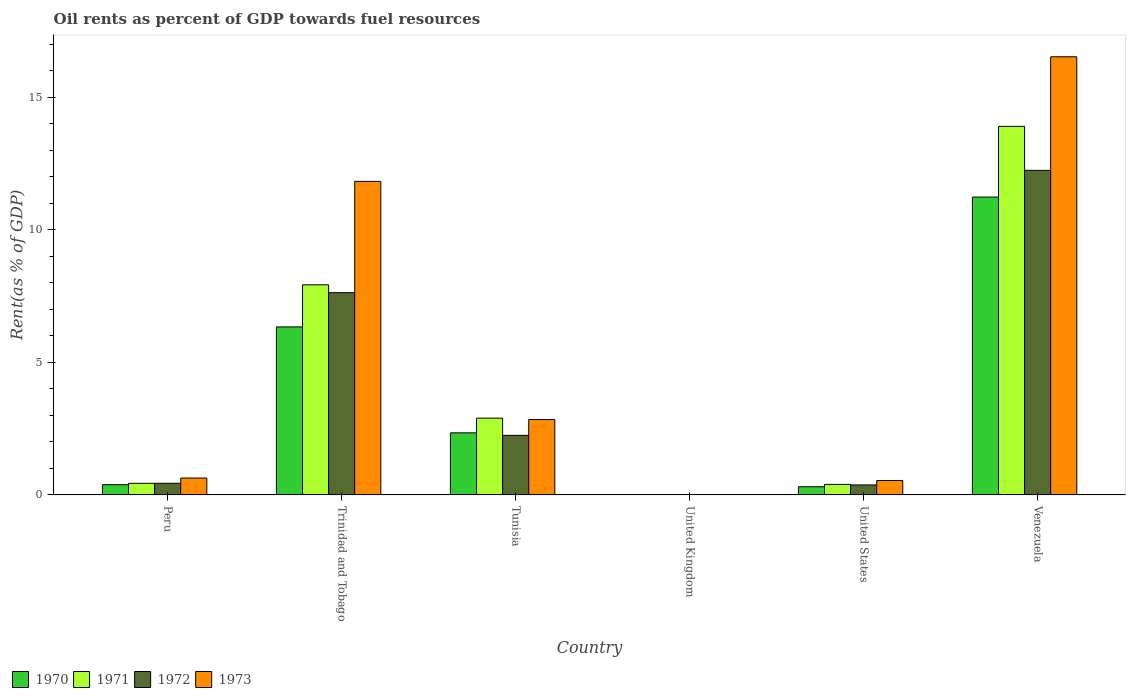How many groups of bars are there?
Provide a short and direct response. 6. Are the number of bars on each tick of the X-axis equal?
Provide a succinct answer. Yes. What is the oil rent in 1972 in Peru?
Keep it short and to the point. 0.44. Across all countries, what is the maximum oil rent in 1971?
Your response must be concise. 13.9. Across all countries, what is the minimum oil rent in 1973?
Your response must be concise. 0. In which country was the oil rent in 1970 maximum?
Keep it short and to the point. Venezuela. In which country was the oil rent in 1971 minimum?
Your answer should be compact. United Kingdom. What is the total oil rent in 1971 in the graph?
Provide a succinct answer. 25.55. What is the difference between the oil rent in 1972 in United States and that in Venezuela?
Provide a short and direct response. -11.86. What is the difference between the oil rent in 1970 in Tunisia and the oil rent in 1973 in Venezuela?
Provide a short and direct response. -14.18. What is the average oil rent in 1970 per country?
Your answer should be very brief. 3.43. What is the difference between the oil rent of/in 1973 and oil rent of/in 1971 in Peru?
Make the answer very short. 0.2. In how many countries, is the oil rent in 1973 greater than 11 %?
Give a very brief answer. 2. What is the ratio of the oil rent in 1972 in United Kingdom to that in United States?
Your answer should be compact. 0. Is the oil rent in 1970 in Tunisia less than that in Venezuela?
Your response must be concise. Yes. Is the difference between the oil rent in 1973 in Trinidad and Tobago and Venezuela greater than the difference between the oil rent in 1971 in Trinidad and Tobago and Venezuela?
Ensure brevity in your answer.  Yes. What is the difference between the highest and the second highest oil rent in 1972?
Your answer should be very brief. -9.99. What is the difference between the highest and the lowest oil rent in 1970?
Keep it short and to the point. 11.23. Is the sum of the oil rent in 1972 in Peru and Venezuela greater than the maximum oil rent in 1970 across all countries?
Make the answer very short. Yes. What does the 1st bar from the left in United States represents?
Your answer should be compact. 1970. What does the 4th bar from the right in Peru represents?
Provide a short and direct response. 1970. Is it the case that in every country, the sum of the oil rent in 1972 and oil rent in 1973 is greater than the oil rent in 1970?
Provide a short and direct response. Yes. How many countries are there in the graph?
Provide a succinct answer. 6. What is the difference between two consecutive major ticks on the Y-axis?
Your answer should be compact. 5. Are the values on the major ticks of Y-axis written in scientific E-notation?
Your response must be concise. No. What is the title of the graph?
Offer a terse response. Oil rents as percent of GDP towards fuel resources. What is the label or title of the Y-axis?
Give a very brief answer. Rent(as % of GDP). What is the Rent(as % of GDP) in 1970 in Peru?
Provide a short and direct response. 0.39. What is the Rent(as % of GDP) in 1971 in Peru?
Ensure brevity in your answer.  0.44. What is the Rent(as % of GDP) in 1972 in Peru?
Keep it short and to the point. 0.44. What is the Rent(as % of GDP) in 1973 in Peru?
Ensure brevity in your answer.  0.64. What is the Rent(as % of GDP) of 1970 in Trinidad and Tobago?
Keep it short and to the point. 6.33. What is the Rent(as % of GDP) of 1971 in Trinidad and Tobago?
Provide a succinct answer. 7.92. What is the Rent(as % of GDP) of 1972 in Trinidad and Tobago?
Offer a terse response. 7.63. What is the Rent(as % of GDP) in 1973 in Trinidad and Tobago?
Make the answer very short. 11.82. What is the Rent(as % of GDP) in 1970 in Tunisia?
Ensure brevity in your answer.  2.34. What is the Rent(as % of GDP) of 1971 in Tunisia?
Your answer should be compact. 2.89. What is the Rent(as % of GDP) of 1972 in Tunisia?
Keep it short and to the point. 2.25. What is the Rent(as % of GDP) of 1973 in Tunisia?
Give a very brief answer. 2.84. What is the Rent(as % of GDP) in 1970 in United Kingdom?
Your response must be concise. 0. What is the Rent(as % of GDP) of 1971 in United Kingdom?
Provide a succinct answer. 0. What is the Rent(as % of GDP) of 1972 in United Kingdom?
Your response must be concise. 0. What is the Rent(as % of GDP) in 1973 in United Kingdom?
Your answer should be very brief. 0. What is the Rent(as % of GDP) of 1970 in United States?
Keep it short and to the point. 0.31. What is the Rent(as % of GDP) in 1971 in United States?
Your response must be concise. 0.4. What is the Rent(as % of GDP) in 1972 in United States?
Offer a terse response. 0.38. What is the Rent(as % of GDP) in 1973 in United States?
Offer a very short reply. 0.54. What is the Rent(as % of GDP) of 1970 in Venezuela?
Offer a very short reply. 11.23. What is the Rent(as % of GDP) of 1971 in Venezuela?
Offer a terse response. 13.9. What is the Rent(as % of GDP) of 1972 in Venezuela?
Make the answer very short. 12.24. What is the Rent(as % of GDP) of 1973 in Venezuela?
Give a very brief answer. 16.52. Across all countries, what is the maximum Rent(as % of GDP) of 1970?
Offer a very short reply. 11.23. Across all countries, what is the maximum Rent(as % of GDP) of 1971?
Your answer should be very brief. 13.9. Across all countries, what is the maximum Rent(as % of GDP) in 1972?
Provide a succinct answer. 12.24. Across all countries, what is the maximum Rent(as % of GDP) of 1973?
Keep it short and to the point. 16.52. Across all countries, what is the minimum Rent(as % of GDP) in 1970?
Your answer should be compact. 0. Across all countries, what is the minimum Rent(as % of GDP) in 1971?
Provide a short and direct response. 0. Across all countries, what is the minimum Rent(as % of GDP) of 1972?
Keep it short and to the point. 0. Across all countries, what is the minimum Rent(as % of GDP) in 1973?
Your answer should be compact. 0. What is the total Rent(as % of GDP) of 1970 in the graph?
Keep it short and to the point. 20.6. What is the total Rent(as % of GDP) in 1971 in the graph?
Offer a terse response. 25.55. What is the total Rent(as % of GDP) of 1972 in the graph?
Make the answer very short. 22.93. What is the total Rent(as % of GDP) of 1973 in the graph?
Make the answer very short. 32.37. What is the difference between the Rent(as % of GDP) of 1970 in Peru and that in Trinidad and Tobago?
Offer a terse response. -5.95. What is the difference between the Rent(as % of GDP) in 1971 in Peru and that in Trinidad and Tobago?
Your answer should be very brief. -7.49. What is the difference between the Rent(as % of GDP) of 1972 in Peru and that in Trinidad and Tobago?
Provide a short and direct response. -7.19. What is the difference between the Rent(as % of GDP) of 1973 in Peru and that in Trinidad and Tobago?
Make the answer very short. -11.19. What is the difference between the Rent(as % of GDP) in 1970 in Peru and that in Tunisia?
Your response must be concise. -1.95. What is the difference between the Rent(as % of GDP) of 1971 in Peru and that in Tunisia?
Provide a succinct answer. -2.46. What is the difference between the Rent(as % of GDP) of 1972 in Peru and that in Tunisia?
Offer a very short reply. -1.81. What is the difference between the Rent(as % of GDP) in 1973 in Peru and that in Tunisia?
Ensure brevity in your answer.  -2.21. What is the difference between the Rent(as % of GDP) of 1970 in Peru and that in United Kingdom?
Provide a short and direct response. 0.38. What is the difference between the Rent(as % of GDP) in 1971 in Peru and that in United Kingdom?
Give a very brief answer. 0.44. What is the difference between the Rent(as % of GDP) of 1972 in Peru and that in United Kingdom?
Offer a terse response. 0.44. What is the difference between the Rent(as % of GDP) in 1973 in Peru and that in United Kingdom?
Your answer should be very brief. 0.63. What is the difference between the Rent(as % of GDP) of 1970 in Peru and that in United States?
Your response must be concise. 0.08. What is the difference between the Rent(as % of GDP) in 1971 in Peru and that in United States?
Keep it short and to the point. 0.04. What is the difference between the Rent(as % of GDP) in 1972 in Peru and that in United States?
Offer a terse response. 0.06. What is the difference between the Rent(as % of GDP) in 1973 in Peru and that in United States?
Offer a terse response. 0.09. What is the difference between the Rent(as % of GDP) of 1970 in Peru and that in Venezuela?
Your answer should be very brief. -10.85. What is the difference between the Rent(as % of GDP) in 1971 in Peru and that in Venezuela?
Make the answer very short. -13.46. What is the difference between the Rent(as % of GDP) of 1972 in Peru and that in Venezuela?
Your response must be concise. -11.8. What is the difference between the Rent(as % of GDP) of 1973 in Peru and that in Venezuela?
Your answer should be compact. -15.89. What is the difference between the Rent(as % of GDP) in 1970 in Trinidad and Tobago and that in Tunisia?
Make the answer very short. 3.99. What is the difference between the Rent(as % of GDP) in 1971 in Trinidad and Tobago and that in Tunisia?
Keep it short and to the point. 5.03. What is the difference between the Rent(as % of GDP) of 1972 in Trinidad and Tobago and that in Tunisia?
Give a very brief answer. 5.38. What is the difference between the Rent(as % of GDP) of 1973 in Trinidad and Tobago and that in Tunisia?
Offer a very short reply. 8.98. What is the difference between the Rent(as % of GDP) in 1970 in Trinidad and Tobago and that in United Kingdom?
Make the answer very short. 6.33. What is the difference between the Rent(as % of GDP) of 1971 in Trinidad and Tobago and that in United Kingdom?
Your answer should be very brief. 7.92. What is the difference between the Rent(as % of GDP) of 1972 in Trinidad and Tobago and that in United Kingdom?
Offer a very short reply. 7.62. What is the difference between the Rent(as % of GDP) in 1973 in Trinidad and Tobago and that in United Kingdom?
Your response must be concise. 11.82. What is the difference between the Rent(as % of GDP) of 1970 in Trinidad and Tobago and that in United States?
Keep it short and to the point. 6.03. What is the difference between the Rent(as % of GDP) of 1971 in Trinidad and Tobago and that in United States?
Provide a succinct answer. 7.53. What is the difference between the Rent(as % of GDP) of 1972 in Trinidad and Tobago and that in United States?
Keep it short and to the point. 7.25. What is the difference between the Rent(as % of GDP) in 1973 in Trinidad and Tobago and that in United States?
Make the answer very short. 11.28. What is the difference between the Rent(as % of GDP) in 1970 in Trinidad and Tobago and that in Venezuela?
Make the answer very short. -4.9. What is the difference between the Rent(as % of GDP) of 1971 in Trinidad and Tobago and that in Venezuela?
Offer a terse response. -5.97. What is the difference between the Rent(as % of GDP) of 1972 in Trinidad and Tobago and that in Venezuela?
Give a very brief answer. -4.61. What is the difference between the Rent(as % of GDP) of 1973 in Trinidad and Tobago and that in Venezuela?
Offer a very short reply. -4.7. What is the difference between the Rent(as % of GDP) of 1970 in Tunisia and that in United Kingdom?
Your response must be concise. 2.34. What is the difference between the Rent(as % of GDP) in 1971 in Tunisia and that in United Kingdom?
Give a very brief answer. 2.89. What is the difference between the Rent(as % of GDP) in 1972 in Tunisia and that in United Kingdom?
Provide a succinct answer. 2.24. What is the difference between the Rent(as % of GDP) of 1973 in Tunisia and that in United Kingdom?
Offer a terse response. 2.84. What is the difference between the Rent(as % of GDP) in 1970 in Tunisia and that in United States?
Ensure brevity in your answer.  2.03. What is the difference between the Rent(as % of GDP) of 1971 in Tunisia and that in United States?
Your answer should be very brief. 2.5. What is the difference between the Rent(as % of GDP) of 1972 in Tunisia and that in United States?
Offer a very short reply. 1.87. What is the difference between the Rent(as % of GDP) of 1973 in Tunisia and that in United States?
Provide a short and direct response. 2.3. What is the difference between the Rent(as % of GDP) in 1970 in Tunisia and that in Venezuela?
Your answer should be very brief. -8.89. What is the difference between the Rent(as % of GDP) in 1971 in Tunisia and that in Venezuela?
Ensure brevity in your answer.  -11. What is the difference between the Rent(as % of GDP) of 1972 in Tunisia and that in Venezuela?
Give a very brief answer. -9.99. What is the difference between the Rent(as % of GDP) of 1973 in Tunisia and that in Venezuela?
Offer a terse response. -13.68. What is the difference between the Rent(as % of GDP) in 1970 in United Kingdom and that in United States?
Offer a terse response. -0.31. What is the difference between the Rent(as % of GDP) in 1971 in United Kingdom and that in United States?
Give a very brief answer. -0.4. What is the difference between the Rent(as % of GDP) in 1972 in United Kingdom and that in United States?
Your answer should be very brief. -0.37. What is the difference between the Rent(as % of GDP) of 1973 in United Kingdom and that in United States?
Your response must be concise. -0.54. What is the difference between the Rent(as % of GDP) in 1970 in United Kingdom and that in Venezuela?
Your answer should be compact. -11.23. What is the difference between the Rent(as % of GDP) in 1971 in United Kingdom and that in Venezuela?
Your answer should be very brief. -13.9. What is the difference between the Rent(as % of GDP) of 1972 in United Kingdom and that in Venezuela?
Offer a very short reply. -12.24. What is the difference between the Rent(as % of GDP) of 1973 in United Kingdom and that in Venezuela?
Make the answer very short. -16.52. What is the difference between the Rent(as % of GDP) of 1970 in United States and that in Venezuela?
Offer a terse response. -10.92. What is the difference between the Rent(as % of GDP) in 1971 in United States and that in Venezuela?
Your answer should be very brief. -13.5. What is the difference between the Rent(as % of GDP) in 1972 in United States and that in Venezuela?
Your response must be concise. -11.86. What is the difference between the Rent(as % of GDP) of 1973 in United States and that in Venezuela?
Your answer should be compact. -15.98. What is the difference between the Rent(as % of GDP) of 1970 in Peru and the Rent(as % of GDP) of 1971 in Trinidad and Tobago?
Provide a succinct answer. -7.54. What is the difference between the Rent(as % of GDP) of 1970 in Peru and the Rent(as % of GDP) of 1972 in Trinidad and Tobago?
Provide a short and direct response. -7.24. What is the difference between the Rent(as % of GDP) in 1970 in Peru and the Rent(as % of GDP) in 1973 in Trinidad and Tobago?
Keep it short and to the point. -11.44. What is the difference between the Rent(as % of GDP) of 1971 in Peru and the Rent(as % of GDP) of 1972 in Trinidad and Tobago?
Give a very brief answer. -7.19. What is the difference between the Rent(as % of GDP) in 1971 in Peru and the Rent(as % of GDP) in 1973 in Trinidad and Tobago?
Make the answer very short. -11.39. What is the difference between the Rent(as % of GDP) of 1972 in Peru and the Rent(as % of GDP) of 1973 in Trinidad and Tobago?
Your response must be concise. -11.38. What is the difference between the Rent(as % of GDP) in 1970 in Peru and the Rent(as % of GDP) in 1971 in Tunisia?
Ensure brevity in your answer.  -2.51. What is the difference between the Rent(as % of GDP) in 1970 in Peru and the Rent(as % of GDP) in 1972 in Tunisia?
Keep it short and to the point. -1.86. What is the difference between the Rent(as % of GDP) in 1970 in Peru and the Rent(as % of GDP) in 1973 in Tunisia?
Your answer should be very brief. -2.46. What is the difference between the Rent(as % of GDP) of 1971 in Peru and the Rent(as % of GDP) of 1972 in Tunisia?
Provide a short and direct response. -1.81. What is the difference between the Rent(as % of GDP) in 1971 in Peru and the Rent(as % of GDP) in 1973 in Tunisia?
Keep it short and to the point. -2.4. What is the difference between the Rent(as % of GDP) in 1972 in Peru and the Rent(as % of GDP) in 1973 in Tunisia?
Your answer should be compact. -2.4. What is the difference between the Rent(as % of GDP) in 1970 in Peru and the Rent(as % of GDP) in 1971 in United Kingdom?
Offer a terse response. 0.38. What is the difference between the Rent(as % of GDP) in 1970 in Peru and the Rent(as % of GDP) in 1972 in United Kingdom?
Keep it short and to the point. 0.38. What is the difference between the Rent(as % of GDP) of 1970 in Peru and the Rent(as % of GDP) of 1973 in United Kingdom?
Keep it short and to the point. 0.38. What is the difference between the Rent(as % of GDP) of 1971 in Peru and the Rent(as % of GDP) of 1972 in United Kingdom?
Make the answer very short. 0.44. What is the difference between the Rent(as % of GDP) of 1971 in Peru and the Rent(as % of GDP) of 1973 in United Kingdom?
Provide a short and direct response. 0.43. What is the difference between the Rent(as % of GDP) of 1972 in Peru and the Rent(as % of GDP) of 1973 in United Kingdom?
Keep it short and to the point. 0.44. What is the difference between the Rent(as % of GDP) of 1970 in Peru and the Rent(as % of GDP) of 1971 in United States?
Make the answer very short. -0.01. What is the difference between the Rent(as % of GDP) in 1970 in Peru and the Rent(as % of GDP) in 1972 in United States?
Ensure brevity in your answer.  0.01. What is the difference between the Rent(as % of GDP) in 1970 in Peru and the Rent(as % of GDP) in 1973 in United States?
Make the answer very short. -0.16. What is the difference between the Rent(as % of GDP) in 1971 in Peru and the Rent(as % of GDP) in 1972 in United States?
Offer a very short reply. 0.06. What is the difference between the Rent(as % of GDP) of 1971 in Peru and the Rent(as % of GDP) of 1973 in United States?
Make the answer very short. -0.11. What is the difference between the Rent(as % of GDP) of 1972 in Peru and the Rent(as % of GDP) of 1973 in United States?
Your answer should be very brief. -0.1. What is the difference between the Rent(as % of GDP) in 1970 in Peru and the Rent(as % of GDP) in 1971 in Venezuela?
Ensure brevity in your answer.  -13.51. What is the difference between the Rent(as % of GDP) in 1970 in Peru and the Rent(as % of GDP) in 1972 in Venezuela?
Your answer should be very brief. -11.85. What is the difference between the Rent(as % of GDP) of 1970 in Peru and the Rent(as % of GDP) of 1973 in Venezuela?
Make the answer very short. -16.14. What is the difference between the Rent(as % of GDP) of 1971 in Peru and the Rent(as % of GDP) of 1972 in Venezuela?
Give a very brief answer. -11.8. What is the difference between the Rent(as % of GDP) in 1971 in Peru and the Rent(as % of GDP) in 1973 in Venezuela?
Your answer should be very brief. -16.08. What is the difference between the Rent(as % of GDP) in 1972 in Peru and the Rent(as % of GDP) in 1973 in Venezuela?
Ensure brevity in your answer.  -16.08. What is the difference between the Rent(as % of GDP) of 1970 in Trinidad and Tobago and the Rent(as % of GDP) of 1971 in Tunisia?
Offer a very short reply. 3.44. What is the difference between the Rent(as % of GDP) of 1970 in Trinidad and Tobago and the Rent(as % of GDP) of 1972 in Tunisia?
Ensure brevity in your answer.  4.09. What is the difference between the Rent(as % of GDP) in 1970 in Trinidad and Tobago and the Rent(as % of GDP) in 1973 in Tunisia?
Your answer should be compact. 3.49. What is the difference between the Rent(as % of GDP) in 1971 in Trinidad and Tobago and the Rent(as % of GDP) in 1972 in Tunisia?
Offer a very short reply. 5.68. What is the difference between the Rent(as % of GDP) in 1971 in Trinidad and Tobago and the Rent(as % of GDP) in 1973 in Tunisia?
Your answer should be very brief. 5.08. What is the difference between the Rent(as % of GDP) of 1972 in Trinidad and Tobago and the Rent(as % of GDP) of 1973 in Tunisia?
Offer a terse response. 4.78. What is the difference between the Rent(as % of GDP) in 1970 in Trinidad and Tobago and the Rent(as % of GDP) in 1971 in United Kingdom?
Offer a very short reply. 6.33. What is the difference between the Rent(as % of GDP) of 1970 in Trinidad and Tobago and the Rent(as % of GDP) of 1972 in United Kingdom?
Ensure brevity in your answer.  6.33. What is the difference between the Rent(as % of GDP) in 1970 in Trinidad and Tobago and the Rent(as % of GDP) in 1973 in United Kingdom?
Offer a terse response. 6.33. What is the difference between the Rent(as % of GDP) of 1971 in Trinidad and Tobago and the Rent(as % of GDP) of 1972 in United Kingdom?
Make the answer very short. 7.92. What is the difference between the Rent(as % of GDP) of 1971 in Trinidad and Tobago and the Rent(as % of GDP) of 1973 in United Kingdom?
Provide a succinct answer. 7.92. What is the difference between the Rent(as % of GDP) of 1972 in Trinidad and Tobago and the Rent(as % of GDP) of 1973 in United Kingdom?
Provide a short and direct response. 7.62. What is the difference between the Rent(as % of GDP) of 1970 in Trinidad and Tobago and the Rent(as % of GDP) of 1971 in United States?
Offer a very short reply. 5.94. What is the difference between the Rent(as % of GDP) of 1970 in Trinidad and Tobago and the Rent(as % of GDP) of 1972 in United States?
Offer a very short reply. 5.96. What is the difference between the Rent(as % of GDP) of 1970 in Trinidad and Tobago and the Rent(as % of GDP) of 1973 in United States?
Your answer should be compact. 5.79. What is the difference between the Rent(as % of GDP) of 1971 in Trinidad and Tobago and the Rent(as % of GDP) of 1972 in United States?
Ensure brevity in your answer.  7.55. What is the difference between the Rent(as % of GDP) of 1971 in Trinidad and Tobago and the Rent(as % of GDP) of 1973 in United States?
Your answer should be compact. 7.38. What is the difference between the Rent(as % of GDP) of 1972 in Trinidad and Tobago and the Rent(as % of GDP) of 1973 in United States?
Make the answer very short. 7.08. What is the difference between the Rent(as % of GDP) in 1970 in Trinidad and Tobago and the Rent(as % of GDP) in 1971 in Venezuela?
Provide a short and direct response. -7.56. What is the difference between the Rent(as % of GDP) of 1970 in Trinidad and Tobago and the Rent(as % of GDP) of 1972 in Venezuela?
Provide a succinct answer. -5.91. What is the difference between the Rent(as % of GDP) of 1970 in Trinidad and Tobago and the Rent(as % of GDP) of 1973 in Venezuela?
Provide a short and direct response. -10.19. What is the difference between the Rent(as % of GDP) of 1971 in Trinidad and Tobago and the Rent(as % of GDP) of 1972 in Venezuela?
Your response must be concise. -4.32. What is the difference between the Rent(as % of GDP) of 1971 in Trinidad and Tobago and the Rent(as % of GDP) of 1973 in Venezuela?
Offer a very short reply. -8.6. What is the difference between the Rent(as % of GDP) in 1972 in Trinidad and Tobago and the Rent(as % of GDP) in 1973 in Venezuela?
Your answer should be very brief. -8.9. What is the difference between the Rent(as % of GDP) of 1970 in Tunisia and the Rent(as % of GDP) of 1971 in United Kingdom?
Provide a succinct answer. 2.34. What is the difference between the Rent(as % of GDP) of 1970 in Tunisia and the Rent(as % of GDP) of 1972 in United Kingdom?
Offer a terse response. 2.34. What is the difference between the Rent(as % of GDP) of 1970 in Tunisia and the Rent(as % of GDP) of 1973 in United Kingdom?
Ensure brevity in your answer.  2.34. What is the difference between the Rent(as % of GDP) of 1971 in Tunisia and the Rent(as % of GDP) of 1972 in United Kingdom?
Your response must be concise. 2.89. What is the difference between the Rent(as % of GDP) of 1971 in Tunisia and the Rent(as % of GDP) of 1973 in United Kingdom?
Your answer should be very brief. 2.89. What is the difference between the Rent(as % of GDP) in 1972 in Tunisia and the Rent(as % of GDP) in 1973 in United Kingdom?
Your answer should be very brief. 2.24. What is the difference between the Rent(as % of GDP) of 1970 in Tunisia and the Rent(as % of GDP) of 1971 in United States?
Provide a succinct answer. 1.94. What is the difference between the Rent(as % of GDP) in 1970 in Tunisia and the Rent(as % of GDP) in 1972 in United States?
Give a very brief answer. 1.96. What is the difference between the Rent(as % of GDP) of 1970 in Tunisia and the Rent(as % of GDP) of 1973 in United States?
Offer a very short reply. 1.8. What is the difference between the Rent(as % of GDP) in 1971 in Tunisia and the Rent(as % of GDP) in 1972 in United States?
Provide a short and direct response. 2.52. What is the difference between the Rent(as % of GDP) of 1971 in Tunisia and the Rent(as % of GDP) of 1973 in United States?
Provide a short and direct response. 2.35. What is the difference between the Rent(as % of GDP) in 1972 in Tunisia and the Rent(as % of GDP) in 1973 in United States?
Ensure brevity in your answer.  1.7. What is the difference between the Rent(as % of GDP) in 1970 in Tunisia and the Rent(as % of GDP) in 1971 in Venezuela?
Your answer should be compact. -11.56. What is the difference between the Rent(as % of GDP) of 1970 in Tunisia and the Rent(as % of GDP) of 1972 in Venezuela?
Provide a short and direct response. -9.9. What is the difference between the Rent(as % of GDP) in 1970 in Tunisia and the Rent(as % of GDP) in 1973 in Venezuela?
Your answer should be compact. -14.18. What is the difference between the Rent(as % of GDP) of 1971 in Tunisia and the Rent(as % of GDP) of 1972 in Venezuela?
Make the answer very short. -9.35. What is the difference between the Rent(as % of GDP) in 1971 in Tunisia and the Rent(as % of GDP) in 1973 in Venezuela?
Provide a short and direct response. -13.63. What is the difference between the Rent(as % of GDP) of 1972 in Tunisia and the Rent(as % of GDP) of 1973 in Venezuela?
Provide a short and direct response. -14.28. What is the difference between the Rent(as % of GDP) of 1970 in United Kingdom and the Rent(as % of GDP) of 1971 in United States?
Provide a succinct answer. -0.4. What is the difference between the Rent(as % of GDP) of 1970 in United Kingdom and the Rent(as % of GDP) of 1972 in United States?
Provide a succinct answer. -0.38. What is the difference between the Rent(as % of GDP) in 1970 in United Kingdom and the Rent(as % of GDP) in 1973 in United States?
Your response must be concise. -0.54. What is the difference between the Rent(as % of GDP) of 1971 in United Kingdom and the Rent(as % of GDP) of 1972 in United States?
Keep it short and to the point. -0.38. What is the difference between the Rent(as % of GDP) in 1971 in United Kingdom and the Rent(as % of GDP) in 1973 in United States?
Keep it short and to the point. -0.54. What is the difference between the Rent(as % of GDP) in 1972 in United Kingdom and the Rent(as % of GDP) in 1973 in United States?
Make the answer very short. -0.54. What is the difference between the Rent(as % of GDP) in 1970 in United Kingdom and the Rent(as % of GDP) in 1971 in Venezuela?
Keep it short and to the point. -13.9. What is the difference between the Rent(as % of GDP) of 1970 in United Kingdom and the Rent(as % of GDP) of 1972 in Venezuela?
Your answer should be compact. -12.24. What is the difference between the Rent(as % of GDP) in 1970 in United Kingdom and the Rent(as % of GDP) in 1973 in Venezuela?
Your response must be concise. -16.52. What is the difference between the Rent(as % of GDP) of 1971 in United Kingdom and the Rent(as % of GDP) of 1972 in Venezuela?
Ensure brevity in your answer.  -12.24. What is the difference between the Rent(as % of GDP) of 1971 in United Kingdom and the Rent(as % of GDP) of 1973 in Venezuela?
Your answer should be compact. -16.52. What is the difference between the Rent(as % of GDP) of 1972 in United Kingdom and the Rent(as % of GDP) of 1973 in Venezuela?
Keep it short and to the point. -16.52. What is the difference between the Rent(as % of GDP) of 1970 in United States and the Rent(as % of GDP) of 1971 in Venezuela?
Your response must be concise. -13.59. What is the difference between the Rent(as % of GDP) of 1970 in United States and the Rent(as % of GDP) of 1972 in Venezuela?
Offer a terse response. -11.93. What is the difference between the Rent(as % of GDP) of 1970 in United States and the Rent(as % of GDP) of 1973 in Venezuela?
Offer a very short reply. -16.21. What is the difference between the Rent(as % of GDP) in 1971 in United States and the Rent(as % of GDP) in 1972 in Venezuela?
Give a very brief answer. -11.84. What is the difference between the Rent(as % of GDP) of 1971 in United States and the Rent(as % of GDP) of 1973 in Venezuela?
Your answer should be very brief. -16.12. What is the difference between the Rent(as % of GDP) of 1972 in United States and the Rent(as % of GDP) of 1973 in Venezuela?
Give a very brief answer. -16.15. What is the average Rent(as % of GDP) in 1970 per country?
Give a very brief answer. 3.43. What is the average Rent(as % of GDP) in 1971 per country?
Provide a succinct answer. 4.26. What is the average Rent(as % of GDP) in 1972 per country?
Your answer should be very brief. 3.82. What is the average Rent(as % of GDP) in 1973 per country?
Provide a short and direct response. 5.39. What is the difference between the Rent(as % of GDP) in 1970 and Rent(as % of GDP) in 1971 in Peru?
Keep it short and to the point. -0.05. What is the difference between the Rent(as % of GDP) of 1970 and Rent(as % of GDP) of 1972 in Peru?
Offer a very short reply. -0.05. What is the difference between the Rent(as % of GDP) in 1970 and Rent(as % of GDP) in 1973 in Peru?
Your response must be concise. -0.25. What is the difference between the Rent(as % of GDP) in 1971 and Rent(as % of GDP) in 1972 in Peru?
Give a very brief answer. -0. What is the difference between the Rent(as % of GDP) of 1971 and Rent(as % of GDP) of 1973 in Peru?
Ensure brevity in your answer.  -0.2. What is the difference between the Rent(as % of GDP) in 1972 and Rent(as % of GDP) in 1973 in Peru?
Give a very brief answer. -0.2. What is the difference between the Rent(as % of GDP) in 1970 and Rent(as % of GDP) in 1971 in Trinidad and Tobago?
Keep it short and to the point. -1.59. What is the difference between the Rent(as % of GDP) in 1970 and Rent(as % of GDP) in 1972 in Trinidad and Tobago?
Provide a short and direct response. -1.29. What is the difference between the Rent(as % of GDP) in 1970 and Rent(as % of GDP) in 1973 in Trinidad and Tobago?
Offer a very short reply. -5.49. What is the difference between the Rent(as % of GDP) of 1971 and Rent(as % of GDP) of 1972 in Trinidad and Tobago?
Make the answer very short. 0.3. What is the difference between the Rent(as % of GDP) in 1971 and Rent(as % of GDP) in 1973 in Trinidad and Tobago?
Your answer should be very brief. -3.9. What is the difference between the Rent(as % of GDP) in 1972 and Rent(as % of GDP) in 1973 in Trinidad and Tobago?
Your answer should be very brief. -4.2. What is the difference between the Rent(as % of GDP) of 1970 and Rent(as % of GDP) of 1971 in Tunisia?
Make the answer very short. -0.55. What is the difference between the Rent(as % of GDP) of 1970 and Rent(as % of GDP) of 1972 in Tunisia?
Make the answer very short. 0.1. What is the difference between the Rent(as % of GDP) in 1970 and Rent(as % of GDP) in 1973 in Tunisia?
Give a very brief answer. -0.5. What is the difference between the Rent(as % of GDP) of 1971 and Rent(as % of GDP) of 1972 in Tunisia?
Give a very brief answer. 0.65. What is the difference between the Rent(as % of GDP) of 1971 and Rent(as % of GDP) of 1973 in Tunisia?
Offer a very short reply. 0.05. What is the difference between the Rent(as % of GDP) of 1972 and Rent(as % of GDP) of 1973 in Tunisia?
Your answer should be very brief. -0.6. What is the difference between the Rent(as % of GDP) of 1970 and Rent(as % of GDP) of 1972 in United Kingdom?
Offer a terse response. -0. What is the difference between the Rent(as % of GDP) in 1970 and Rent(as % of GDP) in 1973 in United Kingdom?
Your answer should be compact. -0. What is the difference between the Rent(as % of GDP) of 1971 and Rent(as % of GDP) of 1972 in United Kingdom?
Your answer should be very brief. -0. What is the difference between the Rent(as % of GDP) of 1971 and Rent(as % of GDP) of 1973 in United Kingdom?
Keep it short and to the point. -0. What is the difference between the Rent(as % of GDP) in 1972 and Rent(as % of GDP) in 1973 in United Kingdom?
Ensure brevity in your answer.  -0. What is the difference between the Rent(as % of GDP) in 1970 and Rent(as % of GDP) in 1971 in United States?
Your answer should be compact. -0.09. What is the difference between the Rent(as % of GDP) in 1970 and Rent(as % of GDP) in 1972 in United States?
Your answer should be compact. -0.07. What is the difference between the Rent(as % of GDP) in 1970 and Rent(as % of GDP) in 1973 in United States?
Provide a succinct answer. -0.23. What is the difference between the Rent(as % of GDP) of 1971 and Rent(as % of GDP) of 1972 in United States?
Your response must be concise. 0.02. What is the difference between the Rent(as % of GDP) in 1971 and Rent(as % of GDP) in 1973 in United States?
Provide a succinct answer. -0.15. What is the difference between the Rent(as % of GDP) of 1972 and Rent(as % of GDP) of 1973 in United States?
Ensure brevity in your answer.  -0.17. What is the difference between the Rent(as % of GDP) in 1970 and Rent(as % of GDP) in 1971 in Venezuela?
Your answer should be compact. -2.67. What is the difference between the Rent(as % of GDP) in 1970 and Rent(as % of GDP) in 1972 in Venezuela?
Ensure brevity in your answer.  -1.01. What is the difference between the Rent(as % of GDP) in 1970 and Rent(as % of GDP) in 1973 in Venezuela?
Your response must be concise. -5.29. What is the difference between the Rent(as % of GDP) in 1971 and Rent(as % of GDP) in 1972 in Venezuela?
Provide a succinct answer. 1.66. What is the difference between the Rent(as % of GDP) in 1971 and Rent(as % of GDP) in 1973 in Venezuela?
Offer a very short reply. -2.62. What is the difference between the Rent(as % of GDP) of 1972 and Rent(as % of GDP) of 1973 in Venezuela?
Keep it short and to the point. -4.28. What is the ratio of the Rent(as % of GDP) of 1970 in Peru to that in Trinidad and Tobago?
Ensure brevity in your answer.  0.06. What is the ratio of the Rent(as % of GDP) of 1971 in Peru to that in Trinidad and Tobago?
Make the answer very short. 0.06. What is the ratio of the Rent(as % of GDP) in 1972 in Peru to that in Trinidad and Tobago?
Provide a short and direct response. 0.06. What is the ratio of the Rent(as % of GDP) in 1973 in Peru to that in Trinidad and Tobago?
Provide a succinct answer. 0.05. What is the ratio of the Rent(as % of GDP) of 1970 in Peru to that in Tunisia?
Your answer should be very brief. 0.16. What is the ratio of the Rent(as % of GDP) of 1971 in Peru to that in Tunisia?
Your response must be concise. 0.15. What is the ratio of the Rent(as % of GDP) of 1972 in Peru to that in Tunisia?
Your answer should be very brief. 0.2. What is the ratio of the Rent(as % of GDP) in 1973 in Peru to that in Tunisia?
Offer a very short reply. 0.22. What is the ratio of the Rent(as % of GDP) of 1970 in Peru to that in United Kingdom?
Give a very brief answer. 435.22. What is the ratio of the Rent(as % of GDP) of 1971 in Peru to that in United Kingdom?
Your answer should be compact. 617.08. What is the ratio of the Rent(as % of GDP) of 1972 in Peru to that in United Kingdom?
Ensure brevity in your answer.  339.21. What is the ratio of the Rent(as % of GDP) of 1973 in Peru to that in United Kingdom?
Ensure brevity in your answer.  283.34. What is the ratio of the Rent(as % of GDP) in 1970 in Peru to that in United States?
Give a very brief answer. 1.25. What is the ratio of the Rent(as % of GDP) of 1971 in Peru to that in United States?
Offer a terse response. 1.1. What is the ratio of the Rent(as % of GDP) in 1972 in Peru to that in United States?
Provide a short and direct response. 1.17. What is the ratio of the Rent(as % of GDP) in 1973 in Peru to that in United States?
Offer a terse response. 1.17. What is the ratio of the Rent(as % of GDP) in 1970 in Peru to that in Venezuela?
Provide a short and direct response. 0.03. What is the ratio of the Rent(as % of GDP) in 1971 in Peru to that in Venezuela?
Make the answer very short. 0.03. What is the ratio of the Rent(as % of GDP) of 1972 in Peru to that in Venezuela?
Offer a very short reply. 0.04. What is the ratio of the Rent(as % of GDP) in 1973 in Peru to that in Venezuela?
Ensure brevity in your answer.  0.04. What is the ratio of the Rent(as % of GDP) of 1970 in Trinidad and Tobago to that in Tunisia?
Keep it short and to the point. 2.71. What is the ratio of the Rent(as % of GDP) in 1971 in Trinidad and Tobago to that in Tunisia?
Your answer should be compact. 2.74. What is the ratio of the Rent(as % of GDP) of 1972 in Trinidad and Tobago to that in Tunisia?
Provide a short and direct response. 3.4. What is the ratio of the Rent(as % of GDP) of 1973 in Trinidad and Tobago to that in Tunisia?
Your answer should be compact. 4.16. What is the ratio of the Rent(as % of GDP) of 1970 in Trinidad and Tobago to that in United Kingdom?
Keep it short and to the point. 7151.98. What is the ratio of the Rent(as % of GDP) of 1971 in Trinidad and Tobago to that in United Kingdom?
Ensure brevity in your answer.  1.12e+04. What is the ratio of the Rent(as % of GDP) in 1972 in Trinidad and Tobago to that in United Kingdom?
Keep it short and to the point. 5894.4. What is the ratio of the Rent(as % of GDP) in 1973 in Trinidad and Tobago to that in United Kingdom?
Ensure brevity in your answer.  5268.85. What is the ratio of the Rent(as % of GDP) of 1970 in Trinidad and Tobago to that in United States?
Ensure brevity in your answer.  20.53. What is the ratio of the Rent(as % of GDP) of 1971 in Trinidad and Tobago to that in United States?
Keep it short and to the point. 19.98. What is the ratio of the Rent(as % of GDP) in 1972 in Trinidad and Tobago to that in United States?
Provide a succinct answer. 20.29. What is the ratio of the Rent(as % of GDP) of 1973 in Trinidad and Tobago to that in United States?
Provide a succinct answer. 21.8. What is the ratio of the Rent(as % of GDP) in 1970 in Trinidad and Tobago to that in Venezuela?
Your answer should be very brief. 0.56. What is the ratio of the Rent(as % of GDP) in 1971 in Trinidad and Tobago to that in Venezuela?
Keep it short and to the point. 0.57. What is the ratio of the Rent(as % of GDP) in 1972 in Trinidad and Tobago to that in Venezuela?
Keep it short and to the point. 0.62. What is the ratio of the Rent(as % of GDP) in 1973 in Trinidad and Tobago to that in Venezuela?
Offer a terse response. 0.72. What is the ratio of the Rent(as % of GDP) in 1970 in Tunisia to that in United Kingdom?
Offer a terse response. 2642.42. What is the ratio of the Rent(as % of GDP) of 1971 in Tunisia to that in United Kingdom?
Ensure brevity in your answer.  4088.61. What is the ratio of the Rent(as % of GDP) in 1972 in Tunisia to that in United Kingdom?
Your answer should be compact. 1735.44. What is the ratio of the Rent(as % of GDP) in 1973 in Tunisia to that in United Kingdom?
Provide a succinct answer. 1266.39. What is the ratio of the Rent(as % of GDP) of 1970 in Tunisia to that in United States?
Offer a very short reply. 7.59. What is the ratio of the Rent(as % of GDP) in 1971 in Tunisia to that in United States?
Offer a terse response. 7.3. What is the ratio of the Rent(as % of GDP) in 1972 in Tunisia to that in United States?
Your answer should be very brief. 5.97. What is the ratio of the Rent(as % of GDP) of 1973 in Tunisia to that in United States?
Offer a very short reply. 5.24. What is the ratio of the Rent(as % of GDP) in 1970 in Tunisia to that in Venezuela?
Ensure brevity in your answer.  0.21. What is the ratio of the Rent(as % of GDP) of 1971 in Tunisia to that in Venezuela?
Offer a very short reply. 0.21. What is the ratio of the Rent(as % of GDP) in 1972 in Tunisia to that in Venezuela?
Offer a terse response. 0.18. What is the ratio of the Rent(as % of GDP) of 1973 in Tunisia to that in Venezuela?
Keep it short and to the point. 0.17. What is the ratio of the Rent(as % of GDP) in 1970 in United Kingdom to that in United States?
Keep it short and to the point. 0. What is the ratio of the Rent(as % of GDP) of 1971 in United Kingdom to that in United States?
Provide a short and direct response. 0. What is the ratio of the Rent(as % of GDP) of 1972 in United Kingdom to that in United States?
Your response must be concise. 0. What is the ratio of the Rent(as % of GDP) of 1973 in United Kingdom to that in United States?
Provide a succinct answer. 0. What is the ratio of the Rent(as % of GDP) in 1971 in United Kingdom to that in Venezuela?
Offer a very short reply. 0. What is the ratio of the Rent(as % of GDP) of 1970 in United States to that in Venezuela?
Your response must be concise. 0.03. What is the ratio of the Rent(as % of GDP) in 1971 in United States to that in Venezuela?
Provide a succinct answer. 0.03. What is the ratio of the Rent(as % of GDP) in 1972 in United States to that in Venezuela?
Provide a succinct answer. 0.03. What is the ratio of the Rent(as % of GDP) of 1973 in United States to that in Venezuela?
Offer a terse response. 0.03. What is the difference between the highest and the second highest Rent(as % of GDP) in 1970?
Your answer should be very brief. 4.9. What is the difference between the highest and the second highest Rent(as % of GDP) of 1971?
Your answer should be very brief. 5.97. What is the difference between the highest and the second highest Rent(as % of GDP) of 1972?
Provide a succinct answer. 4.61. What is the difference between the highest and the second highest Rent(as % of GDP) of 1973?
Give a very brief answer. 4.7. What is the difference between the highest and the lowest Rent(as % of GDP) in 1970?
Offer a very short reply. 11.23. What is the difference between the highest and the lowest Rent(as % of GDP) of 1971?
Offer a terse response. 13.9. What is the difference between the highest and the lowest Rent(as % of GDP) in 1972?
Keep it short and to the point. 12.24. What is the difference between the highest and the lowest Rent(as % of GDP) of 1973?
Keep it short and to the point. 16.52. 